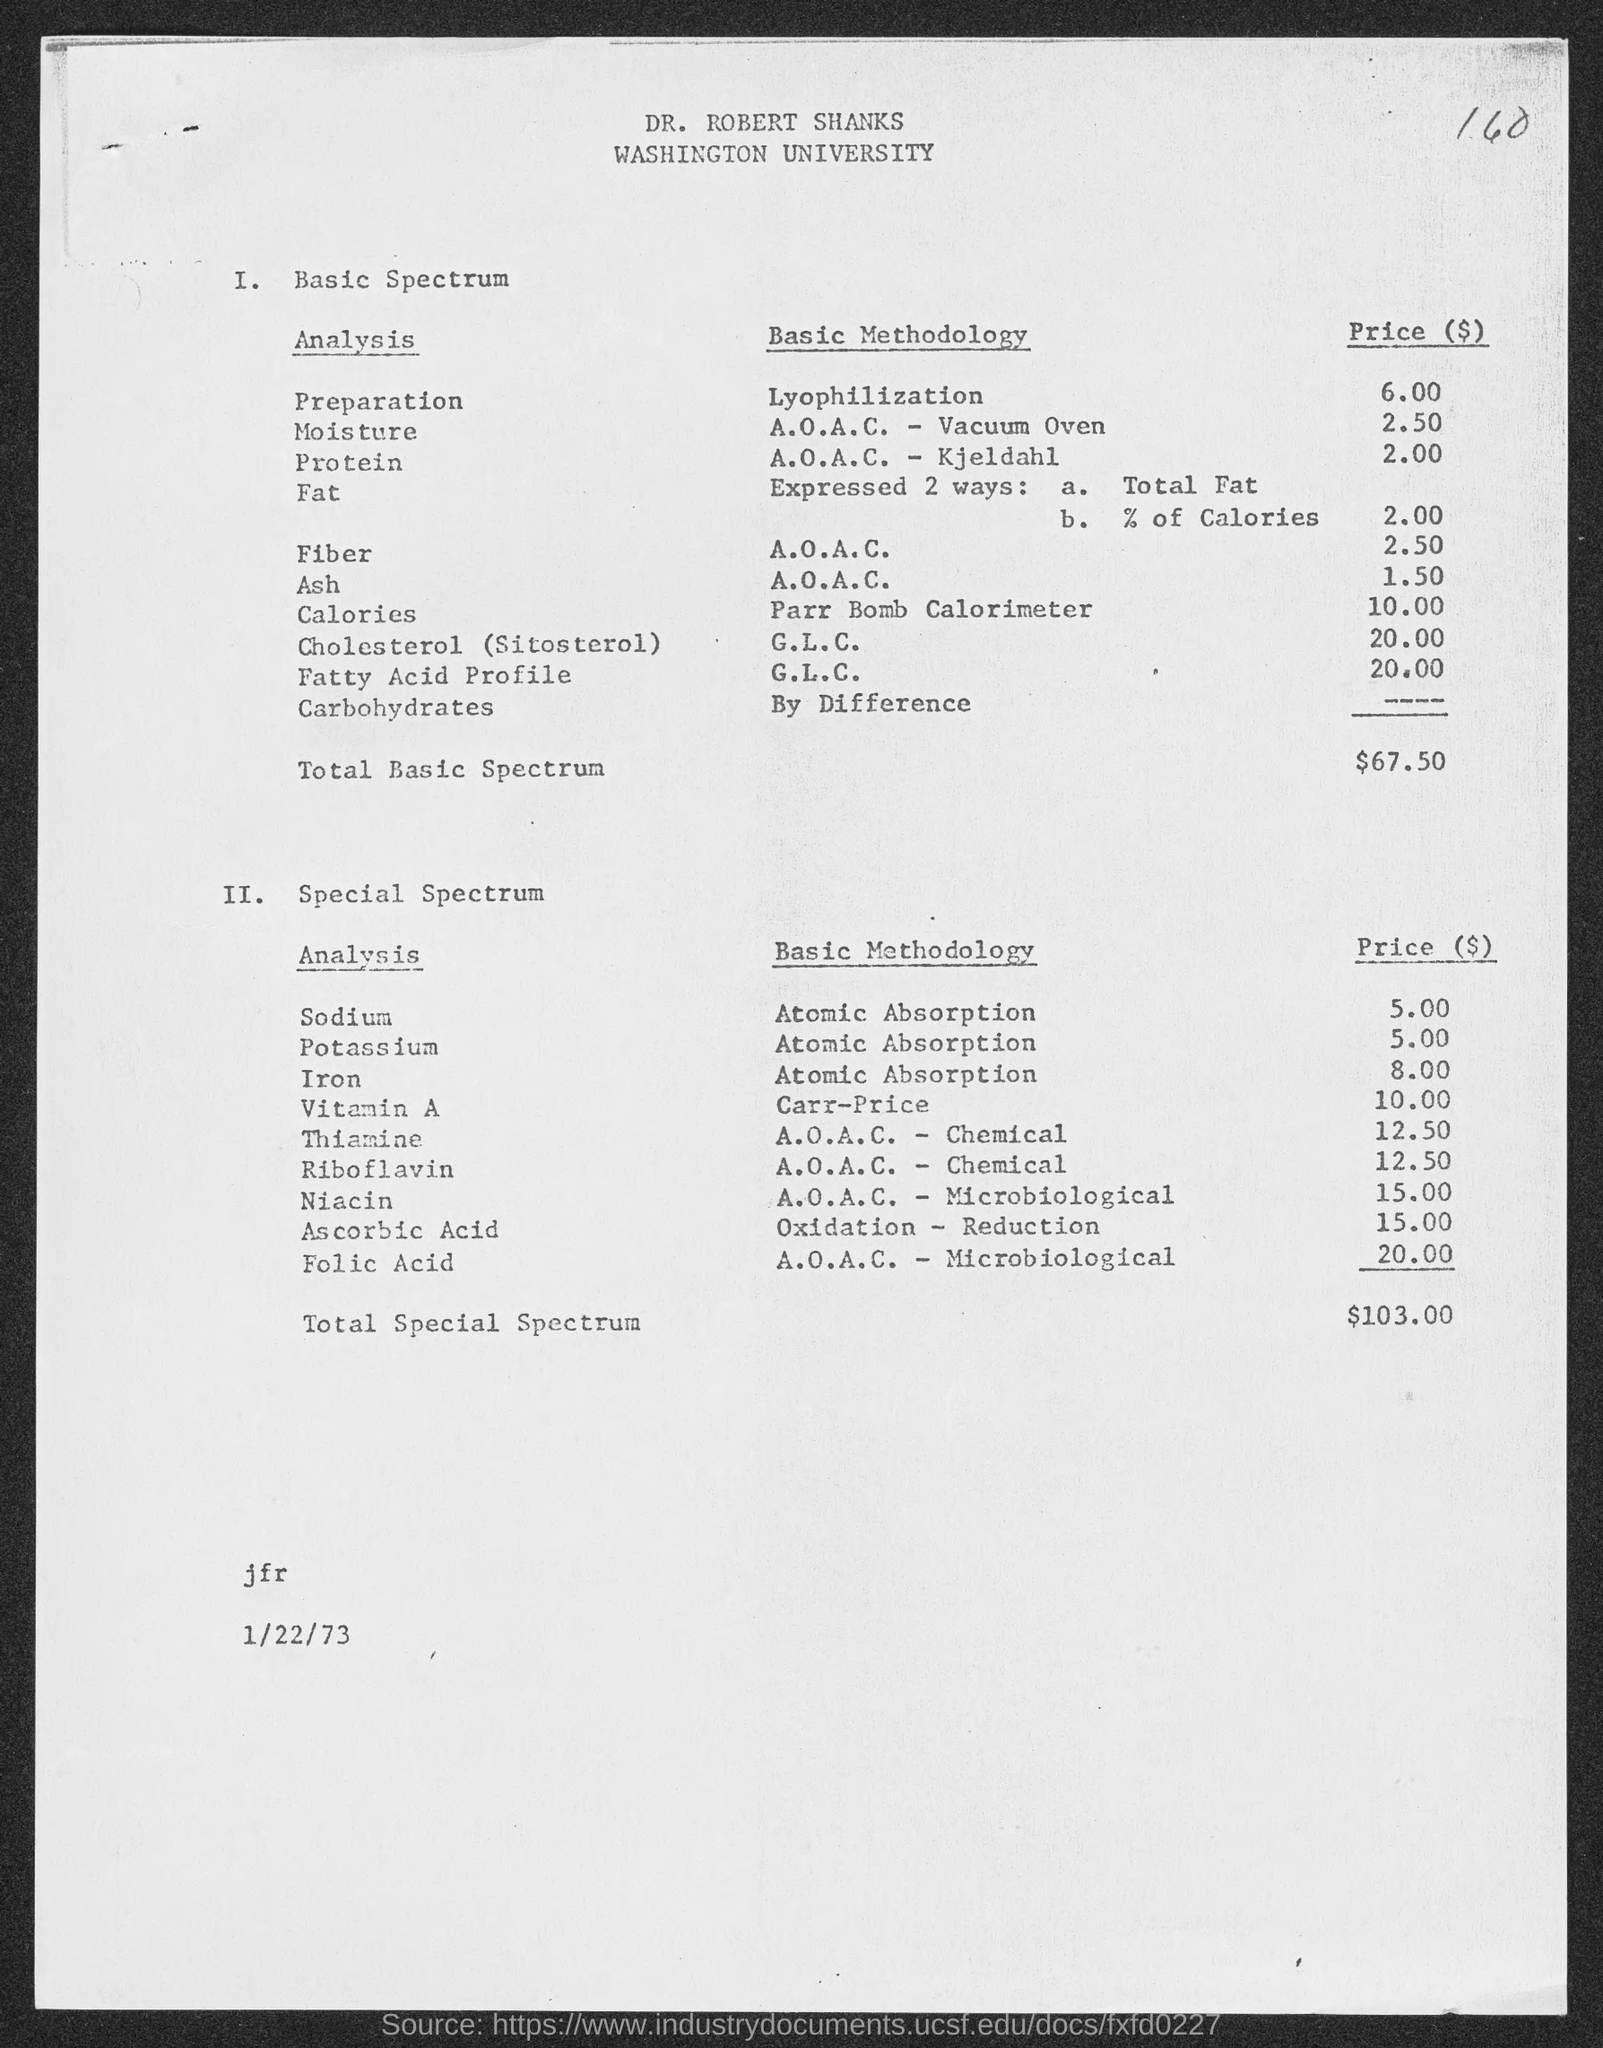What is the name of the university mentioned in the given page ?
Provide a succinct answer. Washington university. What is the price for sodium analysis in atomic absorption methodology ?
Your answer should be very brief. 5.00. What is the price of potassium analysis in atomic absorption methodology ?
Keep it short and to the point. 5.00. What is the price of iron analysis in atomic absorption methodology ?
Your answer should be compact. 8.00. What is the price of vitamin -a analysis in carr- price methodology?
Ensure brevity in your answer.  $ 10.00. What is the price of niacin analysis in a.o.a.c.- microbiological methodology ?
Offer a very short reply. 15.00. What is the amount of total special spectrum mentioned in the given page ?
Your answer should be very brief. $103.00. What is the amount of total basic spectrum mentioned in the given page ?
Ensure brevity in your answer.  $ 67.50. What is the date mentioned in the given page ?
Give a very brief answer. 1/22/73. 